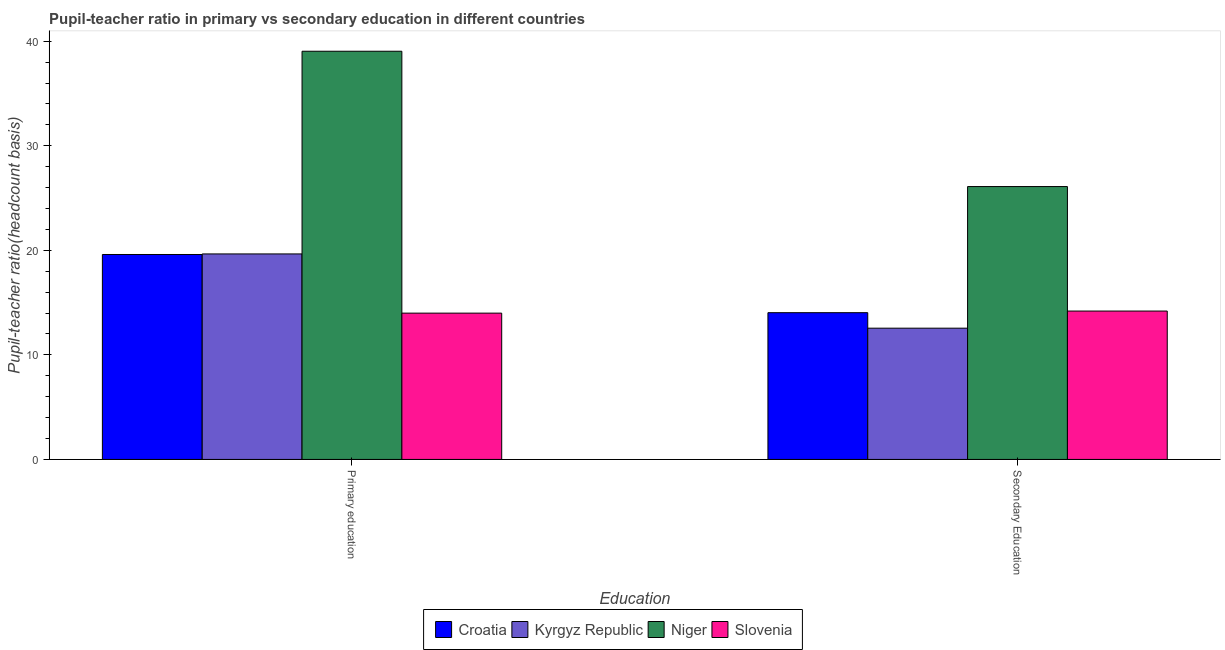How many different coloured bars are there?
Your answer should be very brief. 4. How many groups of bars are there?
Give a very brief answer. 2. Are the number of bars per tick equal to the number of legend labels?
Keep it short and to the point. Yes. Are the number of bars on each tick of the X-axis equal?
Provide a short and direct response. Yes. How many bars are there on the 1st tick from the right?
Ensure brevity in your answer.  4. What is the pupil-teacher ratio in primary education in Slovenia?
Your answer should be very brief. 13.99. Across all countries, what is the maximum pupil-teacher ratio in primary education?
Keep it short and to the point. 39.04. Across all countries, what is the minimum pupil-teacher ratio in primary education?
Offer a very short reply. 13.99. In which country was the pupil teacher ratio on secondary education maximum?
Your response must be concise. Niger. In which country was the pupil teacher ratio on secondary education minimum?
Provide a short and direct response. Kyrgyz Republic. What is the total pupil-teacher ratio in primary education in the graph?
Your answer should be very brief. 92.3. What is the difference between the pupil teacher ratio on secondary education in Kyrgyz Republic and that in Niger?
Your response must be concise. -13.55. What is the difference between the pupil teacher ratio on secondary education in Croatia and the pupil-teacher ratio in primary education in Kyrgyz Republic?
Your response must be concise. -5.62. What is the average pupil-teacher ratio in primary education per country?
Your answer should be very brief. 23.07. What is the difference between the pupil teacher ratio on secondary education and pupil-teacher ratio in primary education in Croatia?
Your response must be concise. -5.57. In how many countries, is the pupil teacher ratio on secondary education greater than 36 ?
Make the answer very short. 0. What is the ratio of the pupil-teacher ratio in primary education in Croatia to that in Kyrgyz Republic?
Give a very brief answer. 1. In how many countries, is the pupil-teacher ratio in primary education greater than the average pupil-teacher ratio in primary education taken over all countries?
Your answer should be compact. 1. What does the 1st bar from the left in Secondary Education represents?
Your answer should be very brief. Croatia. What does the 1st bar from the right in Secondary Education represents?
Offer a terse response. Slovenia. How many bars are there?
Keep it short and to the point. 8. Are all the bars in the graph horizontal?
Provide a succinct answer. No. Are the values on the major ticks of Y-axis written in scientific E-notation?
Your answer should be very brief. No. Does the graph contain grids?
Offer a very short reply. No. How many legend labels are there?
Provide a succinct answer. 4. How are the legend labels stacked?
Ensure brevity in your answer.  Horizontal. What is the title of the graph?
Provide a succinct answer. Pupil-teacher ratio in primary vs secondary education in different countries. What is the label or title of the X-axis?
Offer a terse response. Education. What is the label or title of the Y-axis?
Provide a succinct answer. Pupil-teacher ratio(headcount basis). What is the Pupil-teacher ratio(headcount basis) in Croatia in Primary education?
Provide a short and direct response. 19.6. What is the Pupil-teacher ratio(headcount basis) of Kyrgyz Republic in Primary education?
Offer a terse response. 19.66. What is the Pupil-teacher ratio(headcount basis) in Niger in Primary education?
Your response must be concise. 39.04. What is the Pupil-teacher ratio(headcount basis) of Slovenia in Primary education?
Offer a terse response. 13.99. What is the Pupil-teacher ratio(headcount basis) in Croatia in Secondary Education?
Your answer should be very brief. 14.04. What is the Pupil-teacher ratio(headcount basis) in Kyrgyz Republic in Secondary Education?
Give a very brief answer. 12.55. What is the Pupil-teacher ratio(headcount basis) in Niger in Secondary Education?
Keep it short and to the point. 26.1. What is the Pupil-teacher ratio(headcount basis) in Slovenia in Secondary Education?
Offer a very short reply. 14.19. Across all Education, what is the maximum Pupil-teacher ratio(headcount basis) of Croatia?
Keep it short and to the point. 19.6. Across all Education, what is the maximum Pupil-teacher ratio(headcount basis) of Kyrgyz Republic?
Your answer should be compact. 19.66. Across all Education, what is the maximum Pupil-teacher ratio(headcount basis) of Niger?
Offer a terse response. 39.04. Across all Education, what is the maximum Pupil-teacher ratio(headcount basis) in Slovenia?
Give a very brief answer. 14.19. Across all Education, what is the minimum Pupil-teacher ratio(headcount basis) in Croatia?
Make the answer very short. 14.04. Across all Education, what is the minimum Pupil-teacher ratio(headcount basis) in Kyrgyz Republic?
Provide a short and direct response. 12.55. Across all Education, what is the minimum Pupil-teacher ratio(headcount basis) of Niger?
Offer a terse response. 26.1. Across all Education, what is the minimum Pupil-teacher ratio(headcount basis) of Slovenia?
Offer a terse response. 13.99. What is the total Pupil-teacher ratio(headcount basis) of Croatia in the graph?
Your answer should be compact. 33.64. What is the total Pupil-teacher ratio(headcount basis) of Kyrgyz Republic in the graph?
Offer a terse response. 32.21. What is the total Pupil-teacher ratio(headcount basis) in Niger in the graph?
Offer a terse response. 65.15. What is the total Pupil-teacher ratio(headcount basis) of Slovenia in the graph?
Provide a short and direct response. 28.18. What is the difference between the Pupil-teacher ratio(headcount basis) in Croatia in Primary education and that in Secondary Education?
Provide a succinct answer. 5.57. What is the difference between the Pupil-teacher ratio(headcount basis) in Kyrgyz Republic in Primary education and that in Secondary Education?
Offer a terse response. 7.1. What is the difference between the Pupil-teacher ratio(headcount basis) in Niger in Primary education and that in Secondary Education?
Offer a very short reply. 12.94. What is the difference between the Pupil-teacher ratio(headcount basis) in Slovenia in Primary education and that in Secondary Education?
Keep it short and to the point. -0.2. What is the difference between the Pupil-teacher ratio(headcount basis) of Croatia in Primary education and the Pupil-teacher ratio(headcount basis) of Kyrgyz Republic in Secondary Education?
Offer a very short reply. 7.05. What is the difference between the Pupil-teacher ratio(headcount basis) of Croatia in Primary education and the Pupil-teacher ratio(headcount basis) of Niger in Secondary Education?
Provide a short and direct response. -6.5. What is the difference between the Pupil-teacher ratio(headcount basis) of Croatia in Primary education and the Pupil-teacher ratio(headcount basis) of Slovenia in Secondary Education?
Provide a short and direct response. 5.41. What is the difference between the Pupil-teacher ratio(headcount basis) in Kyrgyz Republic in Primary education and the Pupil-teacher ratio(headcount basis) in Niger in Secondary Education?
Make the answer very short. -6.44. What is the difference between the Pupil-teacher ratio(headcount basis) of Kyrgyz Republic in Primary education and the Pupil-teacher ratio(headcount basis) of Slovenia in Secondary Education?
Give a very brief answer. 5.47. What is the difference between the Pupil-teacher ratio(headcount basis) of Niger in Primary education and the Pupil-teacher ratio(headcount basis) of Slovenia in Secondary Education?
Keep it short and to the point. 24.85. What is the average Pupil-teacher ratio(headcount basis) of Croatia per Education?
Your answer should be very brief. 16.82. What is the average Pupil-teacher ratio(headcount basis) in Kyrgyz Republic per Education?
Offer a very short reply. 16.11. What is the average Pupil-teacher ratio(headcount basis) in Niger per Education?
Give a very brief answer. 32.57. What is the average Pupil-teacher ratio(headcount basis) of Slovenia per Education?
Offer a terse response. 14.09. What is the difference between the Pupil-teacher ratio(headcount basis) in Croatia and Pupil-teacher ratio(headcount basis) in Kyrgyz Republic in Primary education?
Offer a very short reply. -0.05. What is the difference between the Pupil-teacher ratio(headcount basis) in Croatia and Pupil-teacher ratio(headcount basis) in Niger in Primary education?
Keep it short and to the point. -19.44. What is the difference between the Pupil-teacher ratio(headcount basis) of Croatia and Pupil-teacher ratio(headcount basis) of Slovenia in Primary education?
Give a very brief answer. 5.61. What is the difference between the Pupil-teacher ratio(headcount basis) in Kyrgyz Republic and Pupil-teacher ratio(headcount basis) in Niger in Primary education?
Keep it short and to the point. -19.39. What is the difference between the Pupil-teacher ratio(headcount basis) of Kyrgyz Republic and Pupil-teacher ratio(headcount basis) of Slovenia in Primary education?
Keep it short and to the point. 5.66. What is the difference between the Pupil-teacher ratio(headcount basis) of Niger and Pupil-teacher ratio(headcount basis) of Slovenia in Primary education?
Make the answer very short. 25.05. What is the difference between the Pupil-teacher ratio(headcount basis) of Croatia and Pupil-teacher ratio(headcount basis) of Kyrgyz Republic in Secondary Education?
Provide a short and direct response. 1.48. What is the difference between the Pupil-teacher ratio(headcount basis) of Croatia and Pupil-teacher ratio(headcount basis) of Niger in Secondary Education?
Your response must be concise. -12.06. What is the difference between the Pupil-teacher ratio(headcount basis) in Croatia and Pupil-teacher ratio(headcount basis) in Slovenia in Secondary Education?
Make the answer very short. -0.15. What is the difference between the Pupil-teacher ratio(headcount basis) in Kyrgyz Republic and Pupil-teacher ratio(headcount basis) in Niger in Secondary Education?
Make the answer very short. -13.55. What is the difference between the Pupil-teacher ratio(headcount basis) of Kyrgyz Republic and Pupil-teacher ratio(headcount basis) of Slovenia in Secondary Education?
Give a very brief answer. -1.64. What is the difference between the Pupil-teacher ratio(headcount basis) of Niger and Pupil-teacher ratio(headcount basis) of Slovenia in Secondary Education?
Offer a terse response. 11.91. What is the ratio of the Pupil-teacher ratio(headcount basis) in Croatia in Primary education to that in Secondary Education?
Keep it short and to the point. 1.4. What is the ratio of the Pupil-teacher ratio(headcount basis) in Kyrgyz Republic in Primary education to that in Secondary Education?
Offer a very short reply. 1.57. What is the ratio of the Pupil-teacher ratio(headcount basis) in Niger in Primary education to that in Secondary Education?
Make the answer very short. 1.5. What is the ratio of the Pupil-teacher ratio(headcount basis) of Slovenia in Primary education to that in Secondary Education?
Give a very brief answer. 0.99. What is the difference between the highest and the second highest Pupil-teacher ratio(headcount basis) of Croatia?
Your response must be concise. 5.57. What is the difference between the highest and the second highest Pupil-teacher ratio(headcount basis) of Kyrgyz Republic?
Provide a short and direct response. 7.1. What is the difference between the highest and the second highest Pupil-teacher ratio(headcount basis) in Niger?
Provide a succinct answer. 12.94. What is the difference between the highest and the second highest Pupil-teacher ratio(headcount basis) in Slovenia?
Offer a very short reply. 0.2. What is the difference between the highest and the lowest Pupil-teacher ratio(headcount basis) of Croatia?
Keep it short and to the point. 5.57. What is the difference between the highest and the lowest Pupil-teacher ratio(headcount basis) of Kyrgyz Republic?
Give a very brief answer. 7.1. What is the difference between the highest and the lowest Pupil-teacher ratio(headcount basis) of Niger?
Ensure brevity in your answer.  12.94. What is the difference between the highest and the lowest Pupil-teacher ratio(headcount basis) of Slovenia?
Make the answer very short. 0.2. 